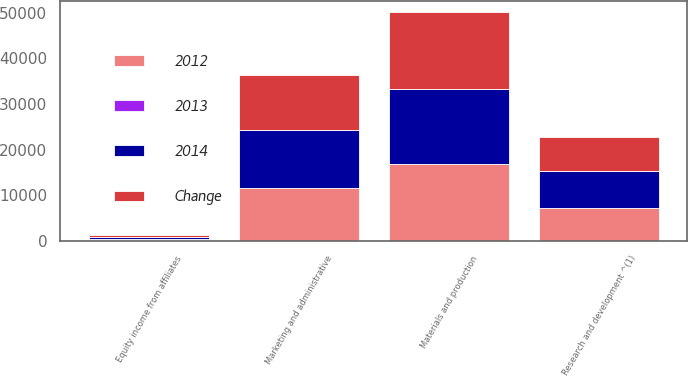<chart> <loc_0><loc_0><loc_500><loc_500><stacked_bar_chart><ecel><fcel>Materials and production<fcel>Marketing and administrative<fcel>Research and development ^(1)<fcel>Equity income from affiliates<nl><fcel>2012<fcel>16768<fcel>11606<fcel>7180<fcel>257<nl><fcel>2013<fcel>1<fcel>3<fcel>4<fcel>36<nl><fcel>Change<fcel>16954<fcel>11911<fcel>7503<fcel>404<nl><fcel>2014<fcel>16446<fcel>12776<fcel>8168<fcel>642<nl></chart> 